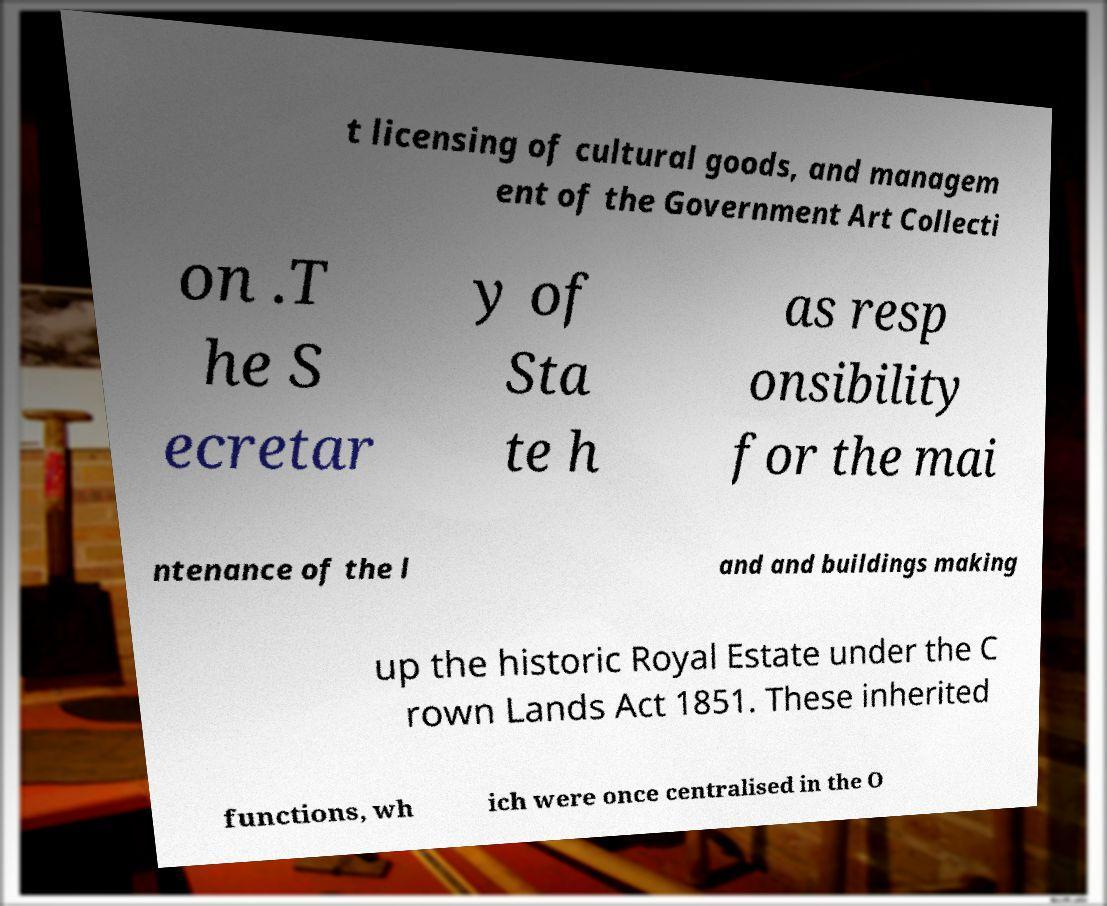Could you assist in decoding the text presented in this image and type it out clearly? t licensing of cultural goods, and managem ent of the Government Art Collecti on .T he S ecretar y of Sta te h as resp onsibility for the mai ntenance of the l and and buildings making up the historic Royal Estate under the C rown Lands Act 1851. These inherited functions, wh ich were once centralised in the O 